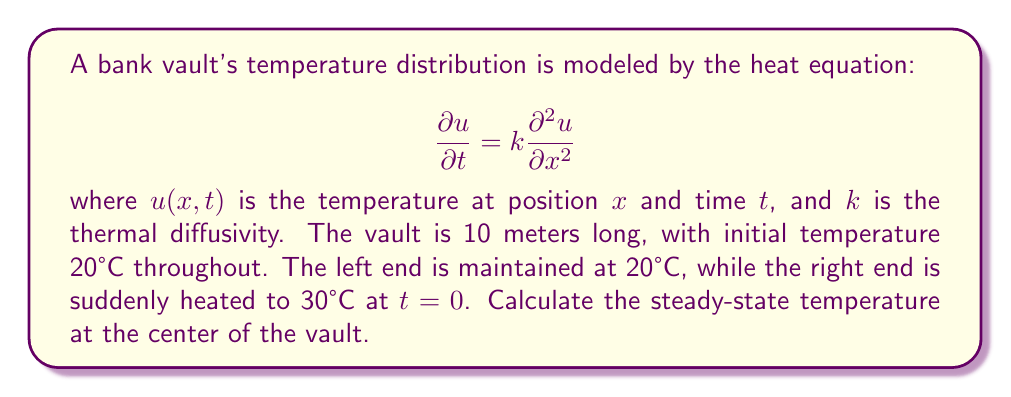Can you solve this math problem? 1) The steady-state solution satisfies $\frac{\partial u}{\partial t} = 0$, reducing the equation to:

   $$\frac{d^2 u}{dx^2} = 0$$

2) The general solution is a linear function:

   $$u(x) = Ax + B$$

3) Boundary conditions:
   At $x = 0$, $u = 20$
   At $x = 10$, $u = 30$

4) Applying these conditions:
   $20 = B$
   $30 = 10A + 20$

5) Solving for $A$ and $B$:
   $B = 20$
   $A = 1$

6) The steady-state solution is:

   $$u(x) = x + 20$$

7) The center of the vault is at $x = 5$. Substituting:

   $$u(5) = 5 + 20 = 25$$

Therefore, the steady-state temperature at the center of the vault is 25°C.
Answer: 25°C 